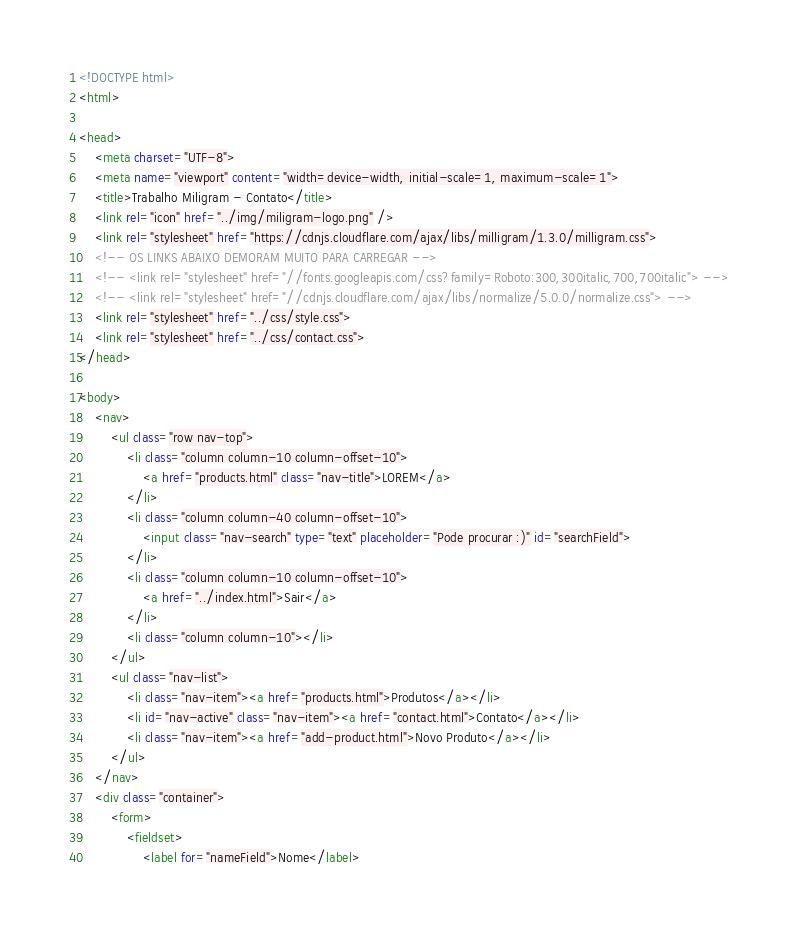<code> <loc_0><loc_0><loc_500><loc_500><_HTML_><!DOCTYPE html>
<html>

<head>
    <meta charset="UTF-8">
    <meta name="viewport" content="width=device-width, initial-scale=1, maximum-scale=1">
    <title>Trabalho Miligram - Contato</title>
    <link rel="icon" href="../img/miligram-logo.png" />
    <link rel="stylesheet" href="https://cdnjs.cloudflare.com/ajax/libs/milligram/1.3.0/milligram.css">
    <!-- OS LINKS ABAIXO DEMORAM MUITO PARA CARREGAR -->
    <!-- <link rel="stylesheet" href="//fonts.googleapis.com/css?family=Roboto:300,300italic,700,700italic"> -->
    <!-- <link rel="stylesheet" href="//cdnjs.cloudflare.com/ajax/libs/normalize/5.0.0/normalize.css"> -->
    <link rel="stylesheet" href="../css/style.css">
    <link rel="stylesheet" href="../css/contact.css">
</head>

<body>
    <nav>
        <ul class="row nav-top">
            <li class="column column-10 column-offset-10">
                <a href="products.html" class="nav-title">LOREM</a>
            </li>
            <li class="column column-40 column-offset-10">
                <input class="nav-search" type="text" placeholder="Pode procurar :)" id="searchField">
            </li>
            <li class="column column-10 column-offset-10">
                <a href="../index.html">Sair</a>
            </li>
            <li class="column column-10"></li>
        </ul>
        <ul class="nav-list">
            <li class="nav-item"><a href="products.html">Produtos</a></li>
            <li id="nav-active" class="nav-item"><a href="contact.html">Contato</a></li>
            <li class="nav-item"><a href="add-product.html">Novo Produto</a></li>
        </ul>
    </nav>
    <div class="container">
        <form>
            <fieldset>
                <label for="nameField">Nome</label></code> 